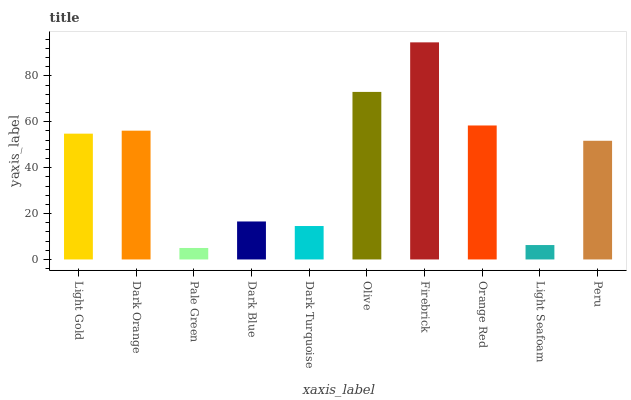Is Pale Green the minimum?
Answer yes or no. Yes. Is Firebrick the maximum?
Answer yes or no. Yes. Is Dark Orange the minimum?
Answer yes or no. No. Is Dark Orange the maximum?
Answer yes or no. No. Is Dark Orange greater than Light Gold?
Answer yes or no. Yes. Is Light Gold less than Dark Orange?
Answer yes or no. Yes. Is Light Gold greater than Dark Orange?
Answer yes or no. No. Is Dark Orange less than Light Gold?
Answer yes or no. No. Is Light Gold the high median?
Answer yes or no. Yes. Is Peru the low median?
Answer yes or no. Yes. Is Firebrick the high median?
Answer yes or no. No. Is Dark Turquoise the low median?
Answer yes or no. No. 